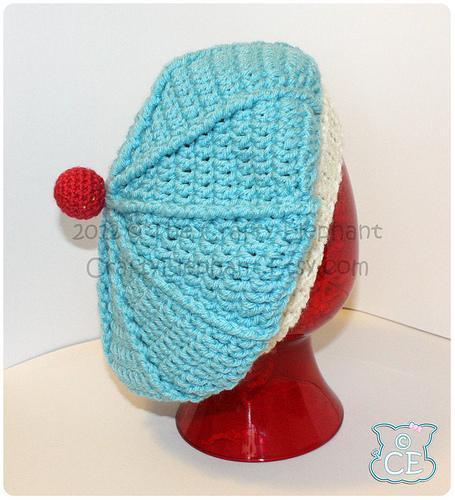How many mannequin's heads are on display?
Give a very brief answer. 1. 